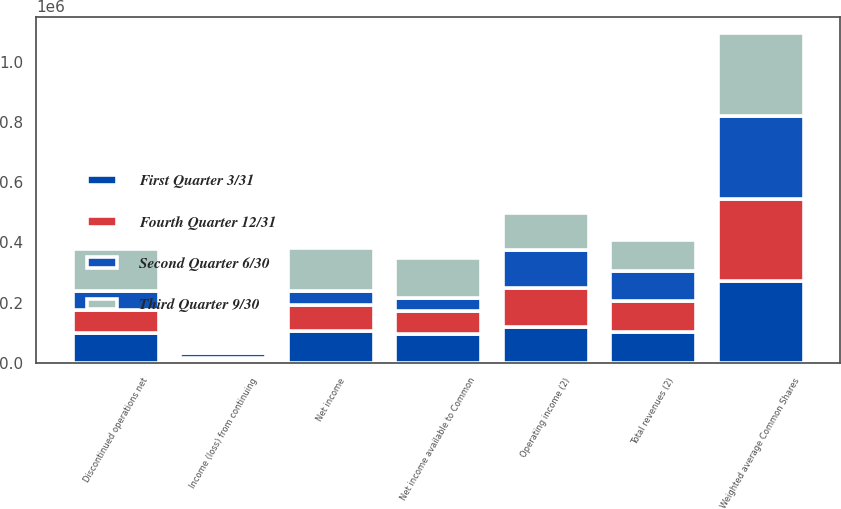<chart> <loc_0><loc_0><loc_500><loc_500><stacked_bar_chart><ecel><fcel>Total revenues (2)<fcel>Operating income (2)<fcel>Income (loss) from continuing<fcel>Discontinued operations net<fcel>Net income<fcel>Net income available to Common<fcel>Weighted average Common Shares<nl><fcel>Fourth Quarter 12/31<fcel>102026<fcel>126283<fcel>7858<fcel>77563<fcel>85421<fcel>77175<fcel>272324<nl><fcel>First Quarter 3/31<fcel>102026<fcel>120661<fcel>7813<fcel>98119<fcel>105932<fcel>96585<fcel>272901<nl><fcel>Third Quarter 9/30<fcel>102026<fcel>122703<fcel>4256<fcel>139109<fcel>143365<fcel>132362<fcel>273658<nl><fcel>Second Quarter 6/30<fcel>102026<fcel>126954<fcel>16996<fcel>64307<fcel>47311<fcel>41672<fcel>275519<nl></chart> 